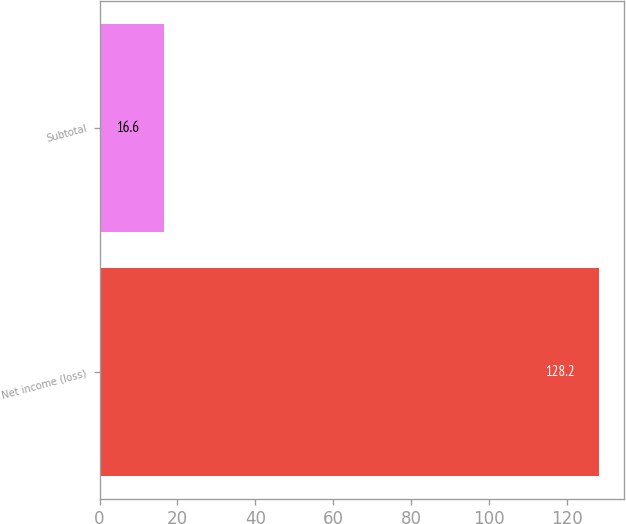Convert chart to OTSL. <chart><loc_0><loc_0><loc_500><loc_500><bar_chart><fcel>Net income (loss)<fcel>Subtotal<nl><fcel>128.2<fcel>16.6<nl></chart> 